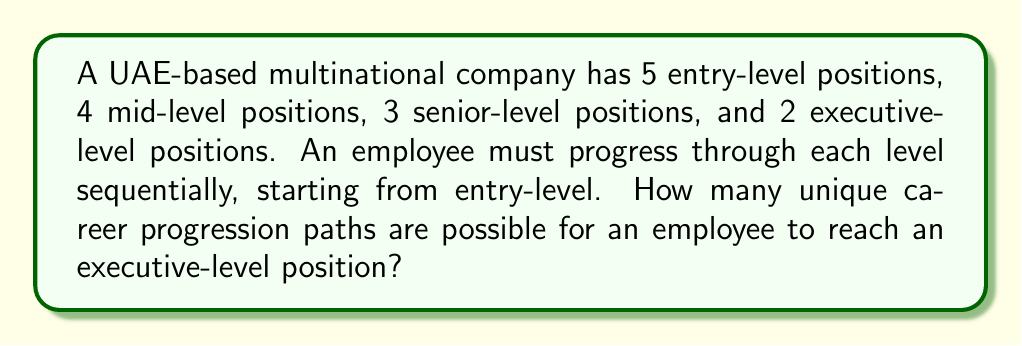Teach me how to tackle this problem. To solve this problem, we need to use the multiplication principle of counting. Here's the step-by-step solution:

1. An employee must choose one position at each level before progressing to the next.

2. At the entry-level, there are 5 choices.

3. At the mid-level, there are 4 choices.

4. At the senior level, there are 3 choices.

5. At the executive level, there are 2 choices.

6. To reach an executive position, an employee must make one choice at each level.

7. According to the multiplication principle, when we have a sequence of choices, we multiply the number of options for each choice to get the total number of possible outcomes.

8. Therefore, the total number of unique career progression paths is:

   $$5 \times 4 \times 3 \times 2 = 120$$

Thus, there are 120 unique career progression paths for an employee to reach an executive-level position in this company structure.
Answer: 120 